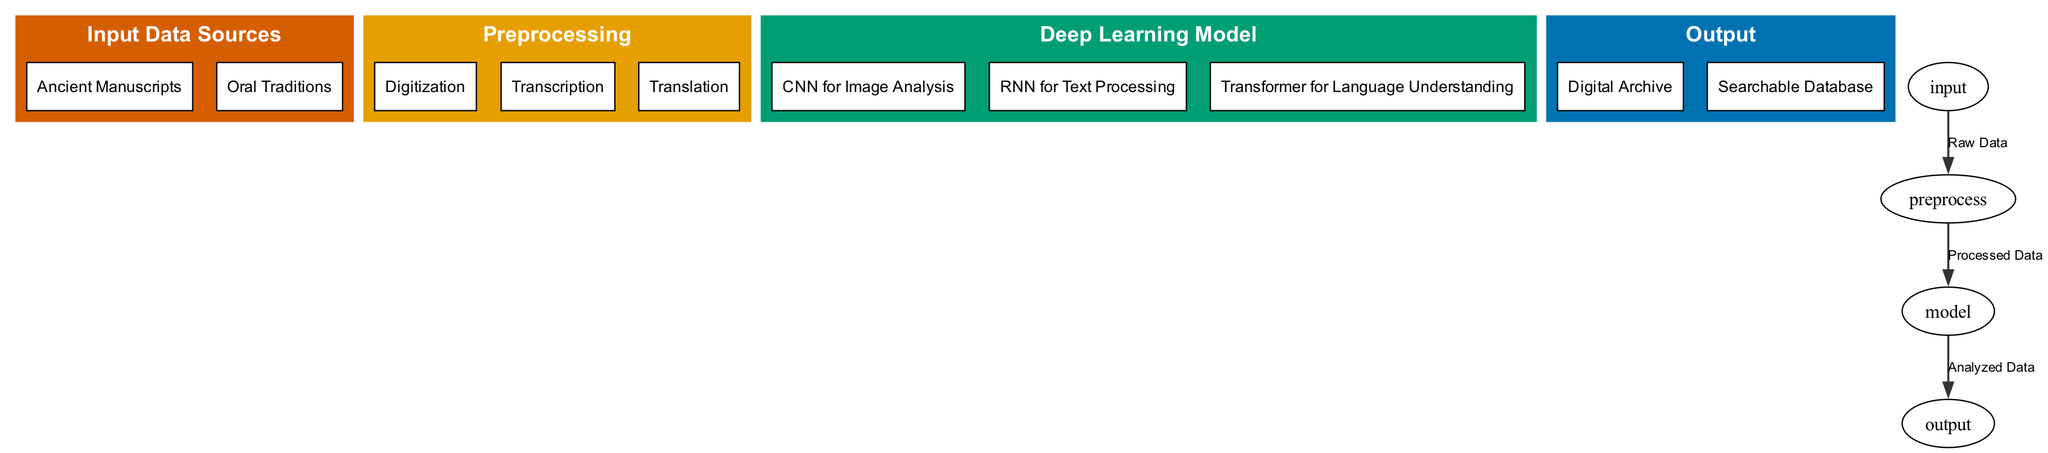What are the main input data sources in the diagram? The diagram shows two main input data sources under the "Input Data Sources" node: "Ancient Manuscripts" and "Oral Traditions". These nodes are listed as the initial points for data acquisition.
Answer: Ancient Manuscripts, Oral Traditions How many preprocessing steps are depicted in the diagram? The diagram lists three preprocessing steps under the "Preprocessing" node: "Digitization", "Transcription", and "Translation". Counting these gives a total of three steps in the preprocessing phase.
Answer: 3 What type of deep learning model is used for image analysis? The "Deep Learning Model" node includes "CNN for Image Analysis" as one of its children, specifically designated for analyzing images, in this case, likely the ancient manuscripts.
Answer: CNN for Image Analysis What is the connection between the preprocessing and the model nodes? The diagram indicates that the edge between the "Preprocessing" node and the "Deep Learning Model" node is labeled "Processed Data". This signifies that the processed data from preprocessing is utilized in the model.
Answer: Processed Data How many output types are generated by the model? The "Output" node in the diagram shows two types: "Digital Archive" and "Searchable Database". Hence, there are two distinct output types that result from the deep learning model's operation.
Answer: 2 What specific machine learning model is applied for text processing? Under the "Deep Learning Model" node, "RNN for Text Processing" is mentioned, which indicates that the RNN model is specifically used for handling textual data within the application.
Answer: RNN for Text Processing What is the last step in the flowchart? The flowchart indicates that after the model processes the data, the final output produced is "Digital Archive" and "Searchable Database", which are positioned under the "Output" node.
Answer: Output Which step follows digitization in the preprocessing phase? The preprocessing phase lists the steps in sequence: "Digitization" is followed by "Transcription", showing a progression from turning physical manuscripts into digital format to converting that format into text.
Answer: Transcription 